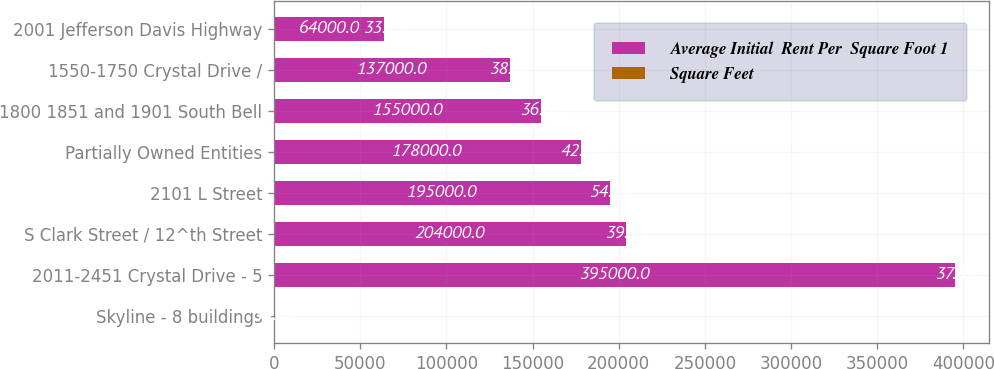Convert chart to OTSL. <chart><loc_0><loc_0><loc_500><loc_500><stacked_bar_chart><ecel><fcel>Skyline - 8 buildings<fcel>2011-2451 Crystal Drive - 5<fcel>S Clark Street / 12^th Street<fcel>2101 L Street<fcel>Partially Owned Entities<fcel>1800 1851 and 1901 South Bell<fcel>1550-1750 Crystal Drive /<fcel>2001 Jefferson Davis Highway<nl><fcel>Average Initial  Rent Per  Square Foot 1<fcel>54.02<fcel>395000<fcel>204000<fcel>195000<fcel>178000<fcel>155000<fcel>137000<fcel>64000<nl><fcel>Square Feet<fcel>33.74<fcel>37.65<fcel>39.55<fcel>54.02<fcel>42.25<fcel>36.08<fcel>38.56<fcel>33.15<nl></chart> 